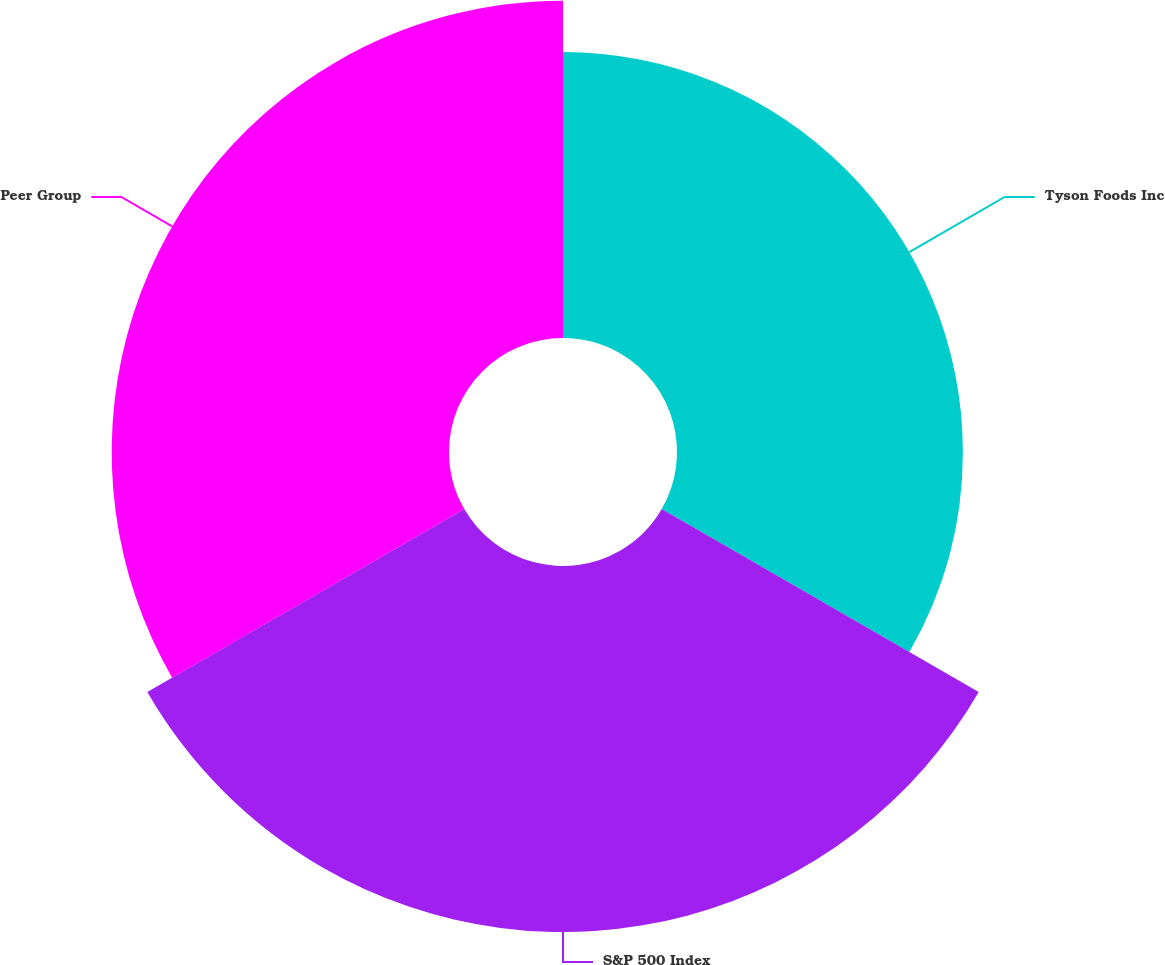Convert chart. <chart><loc_0><loc_0><loc_500><loc_500><pie_chart><fcel>Tyson Foods Inc<fcel>S&P 500 Index<fcel>Peer Group<nl><fcel>28.9%<fcel>37.0%<fcel>34.1%<nl></chart> 